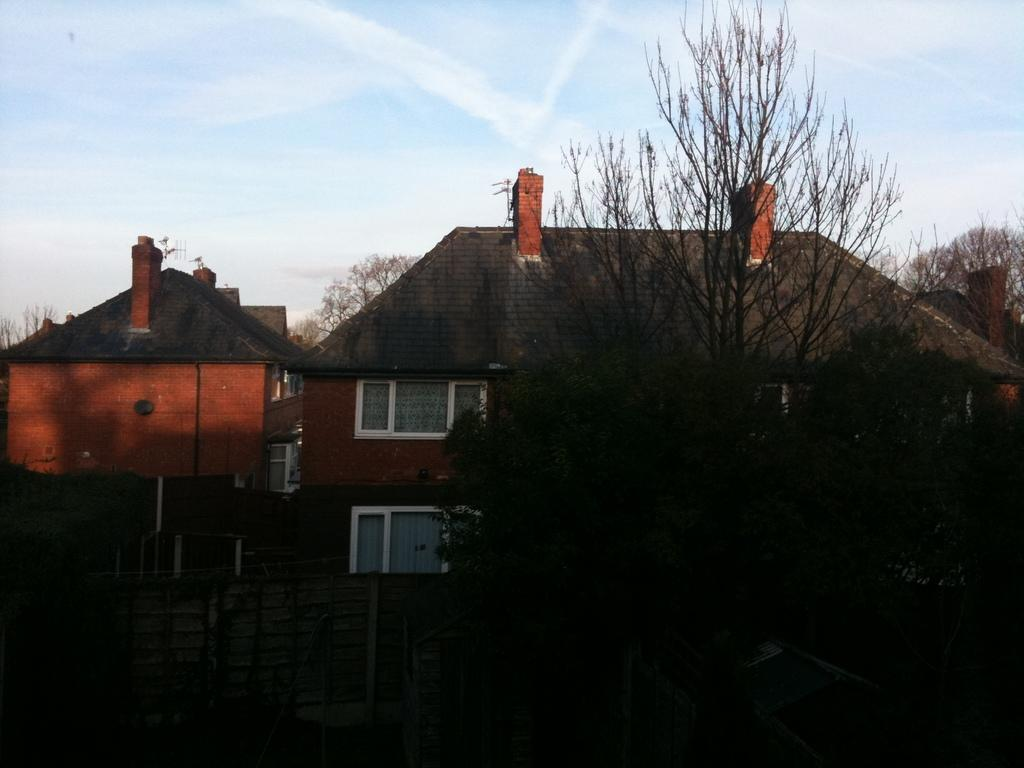What type of vegetation is on the right side of the image? There are trees on the right side of the image. What can be seen in the background of the image? There are buildings with windows in the background of the image. What type of barrier is present in the image? There is a fencing in the image. What is visible in the background of the image? The sky is visible in the background of the image. What type of disease is affecting the trees on the right side of the image? There is no indication of any disease affecting the trees in the image; they appear to be healthy. Can you hear the trees crying in the image? Trees do not have the ability to cry, and there is no sound associated with the image. 